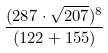<formula> <loc_0><loc_0><loc_500><loc_500>\frac { ( 2 8 7 \cdot \sqrt { 2 0 7 } ) ^ { 8 } } { ( 1 2 2 + 1 5 5 ) }</formula> 